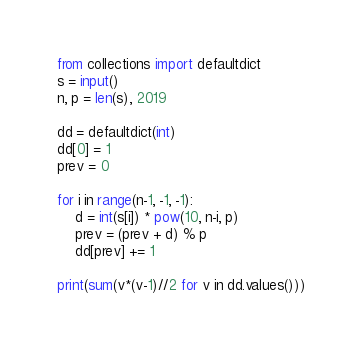Convert code to text. <code><loc_0><loc_0><loc_500><loc_500><_Python_>from collections import defaultdict
s = input()
n, p = len(s), 2019

dd = defaultdict(int)
dd[0] = 1
prev = 0

for i in range(n-1, -1, -1):
    d = int(s[i]) * pow(10, n-i, p)
    prev = (prev + d) % p
    dd[prev] += 1

print(sum(v*(v-1)//2 for v in dd.values()))</code> 